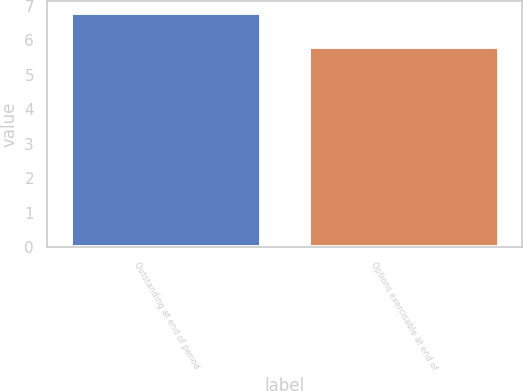Convert chart to OTSL. <chart><loc_0><loc_0><loc_500><loc_500><bar_chart><fcel>Outstanding at end of period<fcel>Options exercisable at end of<nl><fcel>6.8<fcel>5.8<nl></chart> 